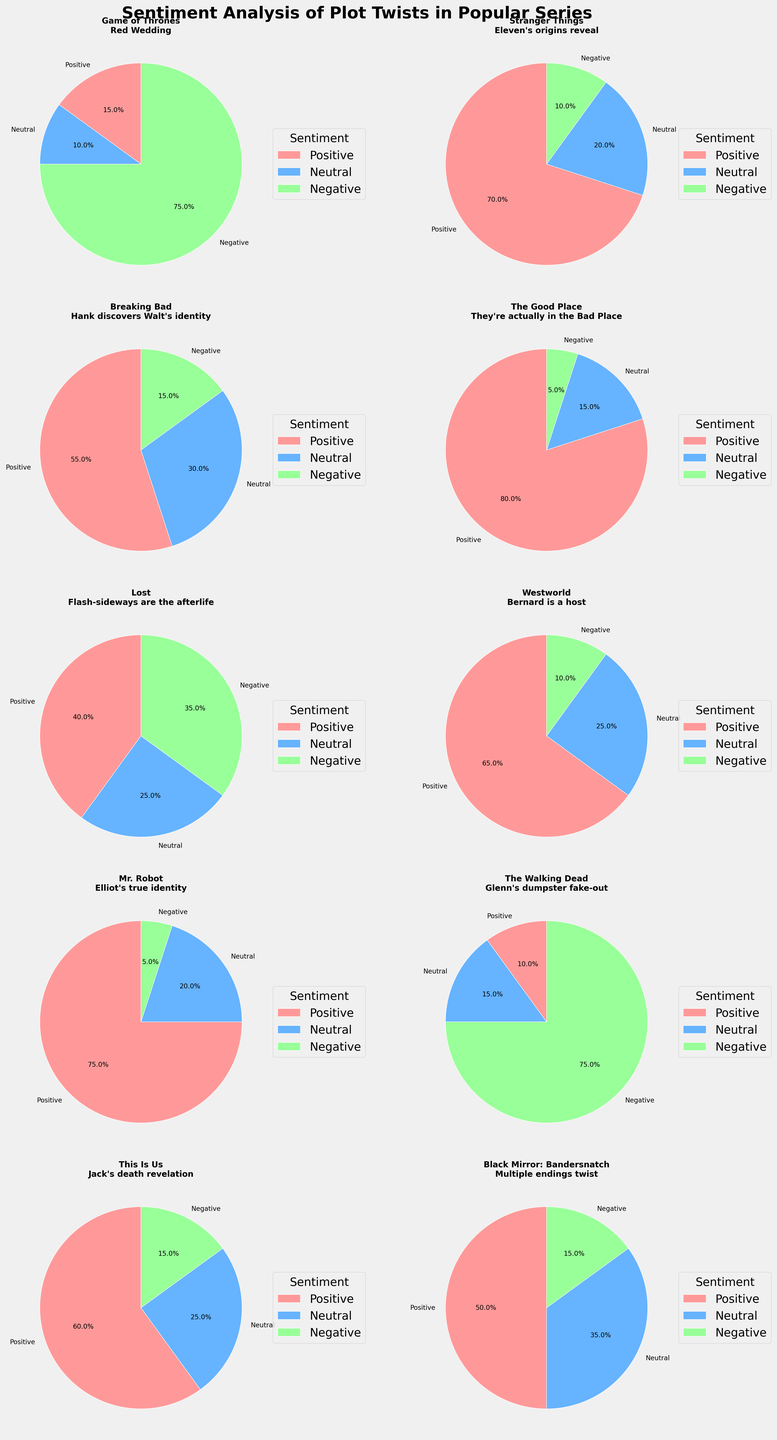What's the title of the figure? The title is shown at the top of the figure and reads "Sentiment Analysis of Plot Twists in Popular Series".
Answer: Sentiment Analysis of Plot Twists in Popular Series Which plot twist from the figure has the highest positive sentiment? Locate the plot twists with their corresponding positive sentiment percentages and identify the highest one. "The Good Place: They're actually in the Bad Place" has 80% positive sentiment, the highest.
Answer: The Good Place: They're actually in the Bad Place How many plot twists have more than 50% negative sentiment? Examine each subplot and count the number of plot twists with negative sentiment percentages over 50%. The two plot twists are "Red Wedding" from "Game of Thrones" and "Glenn's dumpster fake-out" from "The Walking Dead."
Answer: 2 What's the combined positive sentiment percentage for "Eleven's origins reveal" and "Bernard is a host"? Add the positive sentiment percentages for "Eleven's origins reveal" in "Stranger Things" (70%) and "Bernard is a host" in "Westworld" (65%). The combined positive sentiment percentage is 70% + 65% = 135%.
Answer: 135% Which series has a more balanced sentiment distribution between positive, neutral, and negative reactions? Check each subplot to see if the sentiment distribution across positive, neutral, and negative is balanced. "Lost: Flash-sideways are the afterlife" appears to have the most balanced distribution with 40% positive, 25% neutral, and 35% negative.
Answer: Lost: Flash-sideways are the afterlife Which series had the most similar positive and negative sentiment percentages for its plot twist? Compare the positive and negative sentiment percentages in each subplot and identify the closest values. "Black Mirror: Bandersnatch" has 50% positive and 15% negative, which are the closest of any subplots.
Answer: Black Mirror: Bandersnatch What's the difference in positive sentiment between "Mr. Robot" and "Breaking Bad"? Subtract the positive sentiment percentage of "Breaking Bad: Hank discovers Walt's identity" (55%) from "Mr. Robot: Elliot's true identity" (75%). The difference is 75% - 55% = 20%.
Answer: 20% Which plot twist from "Game of Thrones" has the most negative sentiment, and what percentage is it? Look at the "Game of Thrones" subplot title and identify the negative sentiment percentage. The "Red Wedding" has 75% negative sentiment.
Answer: Red Wedding, 75% Out of all the represented series, which plot twist had the highest neutral sentiment? Locate each subplot's neutral sentiment percentage and identify the highest one. "Black Mirror: Bandersnatch" has the highest neutral sentiment at 35%.
Answer: Black Mirror: Bandersnatch 